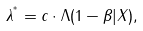<formula> <loc_0><loc_0><loc_500><loc_500>\lambda ^ { ^ { * } } = c \cdot \Lambda ( 1 - \beta | X ) ,</formula> 